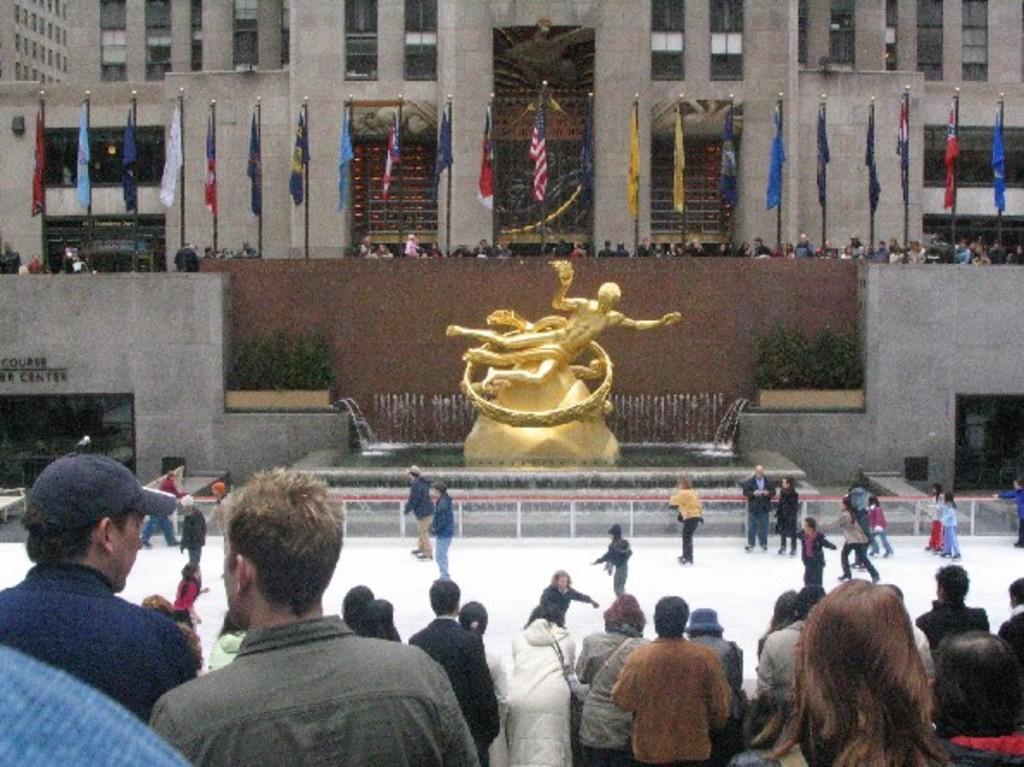Describe this image in one or two sentences. In this picture I can see there is a statue here and it is in golden color and there is a fountain around it. There are few plants and there are few people skating on the ice and they are wearing skating shoes, coats and in the backdrop there are flags attached to the flag poles and there are few more people standing and there is a building behind them, it has windows, doors. There are few people at the bottom of the image and they are watching the people who are skating. 